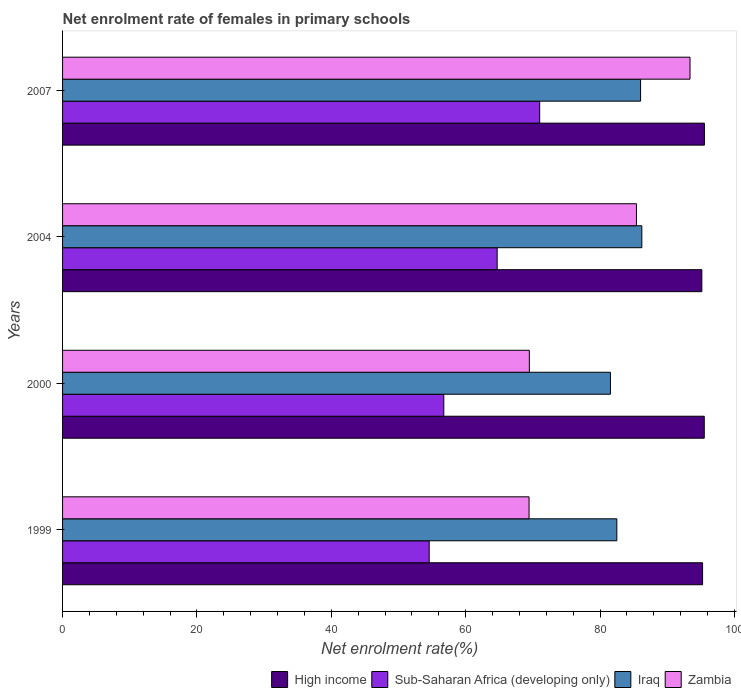How many different coloured bars are there?
Provide a succinct answer. 4. Are the number of bars per tick equal to the number of legend labels?
Provide a succinct answer. Yes. In how many cases, is the number of bars for a given year not equal to the number of legend labels?
Make the answer very short. 0. What is the net enrolment rate of females in primary schools in Sub-Saharan Africa (developing only) in 2007?
Keep it short and to the point. 71.01. Across all years, what is the maximum net enrolment rate of females in primary schools in Zambia?
Provide a short and direct response. 93.38. Across all years, what is the minimum net enrolment rate of females in primary schools in Sub-Saharan Africa (developing only)?
Provide a succinct answer. 54.56. In which year was the net enrolment rate of females in primary schools in Iraq maximum?
Provide a succinct answer. 2004. In which year was the net enrolment rate of females in primary schools in Iraq minimum?
Keep it short and to the point. 2000. What is the total net enrolment rate of females in primary schools in High income in the graph?
Offer a terse response. 381.41. What is the difference between the net enrolment rate of females in primary schools in Iraq in 2000 and that in 2004?
Offer a terse response. -4.67. What is the difference between the net enrolment rate of females in primary schools in Iraq in 2007 and the net enrolment rate of females in primary schools in High income in 1999?
Provide a succinct answer. -9.23. What is the average net enrolment rate of females in primary schools in High income per year?
Ensure brevity in your answer.  95.35. In the year 2000, what is the difference between the net enrolment rate of females in primary schools in High income and net enrolment rate of females in primary schools in Zambia?
Provide a short and direct response. 26.03. In how many years, is the net enrolment rate of females in primary schools in Zambia greater than 88 %?
Give a very brief answer. 1. What is the ratio of the net enrolment rate of females in primary schools in Sub-Saharan Africa (developing only) in 1999 to that in 2000?
Your response must be concise. 0.96. Is the difference between the net enrolment rate of females in primary schools in High income in 2000 and 2007 greater than the difference between the net enrolment rate of females in primary schools in Zambia in 2000 and 2007?
Ensure brevity in your answer.  Yes. What is the difference between the highest and the second highest net enrolment rate of females in primary schools in Sub-Saharan Africa (developing only)?
Provide a succinct answer. 6.33. What is the difference between the highest and the lowest net enrolment rate of females in primary schools in Iraq?
Provide a short and direct response. 4.67. In how many years, is the net enrolment rate of females in primary schools in Zambia greater than the average net enrolment rate of females in primary schools in Zambia taken over all years?
Provide a short and direct response. 2. What does the 1st bar from the bottom in 1999 represents?
Ensure brevity in your answer.  High income. Is it the case that in every year, the sum of the net enrolment rate of females in primary schools in Iraq and net enrolment rate of females in primary schools in High income is greater than the net enrolment rate of females in primary schools in Zambia?
Make the answer very short. Yes. Does the graph contain grids?
Offer a very short reply. No. How are the legend labels stacked?
Provide a short and direct response. Horizontal. What is the title of the graph?
Provide a succinct answer. Net enrolment rate of females in primary schools. Does "Germany" appear as one of the legend labels in the graph?
Offer a terse response. No. What is the label or title of the X-axis?
Your response must be concise. Net enrolment rate(%). What is the Net enrolment rate(%) in High income in 1999?
Offer a very short reply. 95.25. What is the Net enrolment rate(%) in Sub-Saharan Africa (developing only) in 1999?
Keep it short and to the point. 54.56. What is the Net enrolment rate(%) of Iraq in 1999?
Keep it short and to the point. 82.49. What is the Net enrolment rate(%) in Zambia in 1999?
Keep it short and to the point. 69.43. What is the Net enrolment rate(%) of High income in 2000?
Provide a short and direct response. 95.5. What is the Net enrolment rate(%) of Sub-Saharan Africa (developing only) in 2000?
Offer a very short reply. 56.74. What is the Net enrolment rate(%) of Iraq in 2000?
Keep it short and to the point. 81.54. What is the Net enrolment rate(%) of Zambia in 2000?
Give a very brief answer. 69.47. What is the Net enrolment rate(%) of High income in 2004?
Make the answer very short. 95.14. What is the Net enrolment rate(%) of Sub-Saharan Africa (developing only) in 2004?
Offer a very short reply. 64.68. What is the Net enrolment rate(%) of Iraq in 2004?
Keep it short and to the point. 86.21. What is the Net enrolment rate(%) of Zambia in 2004?
Your answer should be very brief. 85.41. What is the Net enrolment rate(%) in High income in 2007?
Make the answer very short. 95.52. What is the Net enrolment rate(%) of Sub-Saharan Africa (developing only) in 2007?
Your response must be concise. 71.01. What is the Net enrolment rate(%) of Iraq in 2007?
Ensure brevity in your answer.  86.02. What is the Net enrolment rate(%) in Zambia in 2007?
Give a very brief answer. 93.38. Across all years, what is the maximum Net enrolment rate(%) in High income?
Ensure brevity in your answer.  95.52. Across all years, what is the maximum Net enrolment rate(%) of Sub-Saharan Africa (developing only)?
Your response must be concise. 71.01. Across all years, what is the maximum Net enrolment rate(%) in Iraq?
Your response must be concise. 86.21. Across all years, what is the maximum Net enrolment rate(%) in Zambia?
Offer a terse response. 93.38. Across all years, what is the minimum Net enrolment rate(%) in High income?
Provide a short and direct response. 95.14. Across all years, what is the minimum Net enrolment rate(%) in Sub-Saharan Africa (developing only)?
Ensure brevity in your answer.  54.56. Across all years, what is the minimum Net enrolment rate(%) in Iraq?
Keep it short and to the point. 81.54. Across all years, what is the minimum Net enrolment rate(%) of Zambia?
Give a very brief answer. 69.43. What is the total Net enrolment rate(%) of High income in the graph?
Provide a short and direct response. 381.41. What is the total Net enrolment rate(%) in Sub-Saharan Africa (developing only) in the graph?
Your response must be concise. 246.99. What is the total Net enrolment rate(%) of Iraq in the graph?
Your answer should be very brief. 336.25. What is the total Net enrolment rate(%) of Zambia in the graph?
Your response must be concise. 317.69. What is the difference between the Net enrolment rate(%) in High income in 1999 and that in 2000?
Your answer should be very brief. -0.25. What is the difference between the Net enrolment rate(%) of Sub-Saharan Africa (developing only) in 1999 and that in 2000?
Keep it short and to the point. -2.17. What is the difference between the Net enrolment rate(%) of Iraq in 1999 and that in 2000?
Your response must be concise. 0.95. What is the difference between the Net enrolment rate(%) in Zambia in 1999 and that in 2000?
Provide a succinct answer. -0.04. What is the difference between the Net enrolment rate(%) of High income in 1999 and that in 2004?
Your answer should be very brief. 0.11. What is the difference between the Net enrolment rate(%) in Sub-Saharan Africa (developing only) in 1999 and that in 2004?
Offer a very short reply. -10.12. What is the difference between the Net enrolment rate(%) of Iraq in 1999 and that in 2004?
Your answer should be very brief. -3.72. What is the difference between the Net enrolment rate(%) in Zambia in 1999 and that in 2004?
Keep it short and to the point. -15.99. What is the difference between the Net enrolment rate(%) of High income in 1999 and that in 2007?
Your response must be concise. -0.27. What is the difference between the Net enrolment rate(%) in Sub-Saharan Africa (developing only) in 1999 and that in 2007?
Give a very brief answer. -16.44. What is the difference between the Net enrolment rate(%) in Iraq in 1999 and that in 2007?
Your response must be concise. -3.53. What is the difference between the Net enrolment rate(%) in Zambia in 1999 and that in 2007?
Offer a terse response. -23.96. What is the difference between the Net enrolment rate(%) in High income in 2000 and that in 2004?
Offer a terse response. 0.36. What is the difference between the Net enrolment rate(%) of Sub-Saharan Africa (developing only) in 2000 and that in 2004?
Your answer should be very brief. -7.94. What is the difference between the Net enrolment rate(%) of Iraq in 2000 and that in 2004?
Give a very brief answer. -4.67. What is the difference between the Net enrolment rate(%) of Zambia in 2000 and that in 2004?
Offer a terse response. -15.94. What is the difference between the Net enrolment rate(%) in High income in 2000 and that in 2007?
Your answer should be very brief. -0.02. What is the difference between the Net enrolment rate(%) of Sub-Saharan Africa (developing only) in 2000 and that in 2007?
Your answer should be compact. -14.27. What is the difference between the Net enrolment rate(%) in Iraq in 2000 and that in 2007?
Offer a terse response. -4.48. What is the difference between the Net enrolment rate(%) of Zambia in 2000 and that in 2007?
Offer a very short reply. -23.91. What is the difference between the Net enrolment rate(%) of High income in 2004 and that in 2007?
Your answer should be very brief. -0.38. What is the difference between the Net enrolment rate(%) in Sub-Saharan Africa (developing only) in 2004 and that in 2007?
Offer a terse response. -6.33. What is the difference between the Net enrolment rate(%) of Iraq in 2004 and that in 2007?
Your answer should be very brief. 0.19. What is the difference between the Net enrolment rate(%) of Zambia in 2004 and that in 2007?
Give a very brief answer. -7.97. What is the difference between the Net enrolment rate(%) of High income in 1999 and the Net enrolment rate(%) of Sub-Saharan Africa (developing only) in 2000?
Offer a terse response. 38.51. What is the difference between the Net enrolment rate(%) of High income in 1999 and the Net enrolment rate(%) of Iraq in 2000?
Offer a terse response. 13.71. What is the difference between the Net enrolment rate(%) in High income in 1999 and the Net enrolment rate(%) in Zambia in 2000?
Your answer should be very brief. 25.78. What is the difference between the Net enrolment rate(%) in Sub-Saharan Africa (developing only) in 1999 and the Net enrolment rate(%) in Iraq in 2000?
Your answer should be very brief. -26.97. What is the difference between the Net enrolment rate(%) of Sub-Saharan Africa (developing only) in 1999 and the Net enrolment rate(%) of Zambia in 2000?
Offer a very short reply. -14.9. What is the difference between the Net enrolment rate(%) in Iraq in 1999 and the Net enrolment rate(%) in Zambia in 2000?
Provide a succinct answer. 13.02. What is the difference between the Net enrolment rate(%) of High income in 1999 and the Net enrolment rate(%) of Sub-Saharan Africa (developing only) in 2004?
Offer a terse response. 30.57. What is the difference between the Net enrolment rate(%) of High income in 1999 and the Net enrolment rate(%) of Iraq in 2004?
Your answer should be very brief. 9.04. What is the difference between the Net enrolment rate(%) in High income in 1999 and the Net enrolment rate(%) in Zambia in 2004?
Your answer should be compact. 9.84. What is the difference between the Net enrolment rate(%) of Sub-Saharan Africa (developing only) in 1999 and the Net enrolment rate(%) of Iraq in 2004?
Provide a short and direct response. -31.65. What is the difference between the Net enrolment rate(%) of Sub-Saharan Africa (developing only) in 1999 and the Net enrolment rate(%) of Zambia in 2004?
Your answer should be compact. -30.85. What is the difference between the Net enrolment rate(%) of Iraq in 1999 and the Net enrolment rate(%) of Zambia in 2004?
Ensure brevity in your answer.  -2.92. What is the difference between the Net enrolment rate(%) of High income in 1999 and the Net enrolment rate(%) of Sub-Saharan Africa (developing only) in 2007?
Your response must be concise. 24.24. What is the difference between the Net enrolment rate(%) of High income in 1999 and the Net enrolment rate(%) of Iraq in 2007?
Make the answer very short. 9.23. What is the difference between the Net enrolment rate(%) in High income in 1999 and the Net enrolment rate(%) in Zambia in 2007?
Provide a short and direct response. 1.87. What is the difference between the Net enrolment rate(%) in Sub-Saharan Africa (developing only) in 1999 and the Net enrolment rate(%) in Iraq in 2007?
Your answer should be compact. -31.46. What is the difference between the Net enrolment rate(%) of Sub-Saharan Africa (developing only) in 1999 and the Net enrolment rate(%) of Zambia in 2007?
Keep it short and to the point. -38.82. What is the difference between the Net enrolment rate(%) of Iraq in 1999 and the Net enrolment rate(%) of Zambia in 2007?
Give a very brief answer. -10.89. What is the difference between the Net enrolment rate(%) in High income in 2000 and the Net enrolment rate(%) in Sub-Saharan Africa (developing only) in 2004?
Offer a terse response. 30.82. What is the difference between the Net enrolment rate(%) of High income in 2000 and the Net enrolment rate(%) of Iraq in 2004?
Offer a very short reply. 9.29. What is the difference between the Net enrolment rate(%) in High income in 2000 and the Net enrolment rate(%) in Zambia in 2004?
Provide a short and direct response. 10.09. What is the difference between the Net enrolment rate(%) of Sub-Saharan Africa (developing only) in 2000 and the Net enrolment rate(%) of Iraq in 2004?
Offer a very short reply. -29.47. What is the difference between the Net enrolment rate(%) in Sub-Saharan Africa (developing only) in 2000 and the Net enrolment rate(%) in Zambia in 2004?
Provide a short and direct response. -28.68. What is the difference between the Net enrolment rate(%) of Iraq in 2000 and the Net enrolment rate(%) of Zambia in 2004?
Your answer should be compact. -3.88. What is the difference between the Net enrolment rate(%) in High income in 2000 and the Net enrolment rate(%) in Sub-Saharan Africa (developing only) in 2007?
Your answer should be very brief. 24.49. What is the difference between the Net enrolment rate(%) of High income in 2000 and the Net enrolment rate(%) of Iraq in 2007?
Provide a succinct answer. 9.48. What is the difference between the Net enrolment rate(%) in High income in 2000 and the Net enrolment rate(%) in Zambia in 2007?
Offer a terse response. 2.12. What is the difference between the Net enrolment rate(%) of Sub-Saharan Africa (developing only) in 2000 and the Net enrolment rate(%) of Iraq in 2007?
Your answer should be very brief. -29.29. What is the difference between the Net enrolment rate(%) of Sub-Saharan Africa (developing only) in 2000 and the Net enrolment rate(%) of Zambia in 2007?
Your response must be concise. -36.65. What is the difference between the Net enrolment rate(%) in Iraq in 2000 and the Net enrolment rate(%) in Zambia in 2007?
Provide a succinct answer. -11.84. What is the difference between the Net enrolment rate(%) of High income in 2004 and the Net enrolment rate(%) of Sub-Saharan Africa (developing only) in 2007?
Your answer should be compact. 24.13. What is the difference between the Net enrolment rate(%) of High income in 2004 and the Net enrolment rate(%) of Iraq in 2007?
Give a very brief answer. 9.12. What is the difference between the Net enrolment rate(%) in High income in 2004 and the Net enrolment rate(%) in Zambia in 2007?
Provide a short and direct response. 1.76. What is the difference between the Net enrolment rate(%) of Sub-Saharan Africa (developing only) in 2004 and the Net enrolment rate(%) of Iraq in 2007?
Your response must be concise. -21.34. What is the difference between the Net enrolment rate(%) in Sub-Saharan Africa (developing only) in 2004 and the Net enrolment rate(%) in Zambia in 2007?
Provide a short and direct response. -28.7. What is the difference between the Net enrolment rate(%) of Iraq in 2004 and the Net enrolment rate(%) of Zambia in 2007?
Provide a succinct answer. -7.17. What is the average Net enrolment rate(%) of High income per year?
Offer a terse response. 95.35. What is the average Net enrolment rate(%) in Sub-Saharan Africa (developing only) per year?
Offer a terse response. 61.75. What is the average Net enrolment rate(%) in Iraq per year?
Provide a short and direct response. 84.06. What is the average Net enrolment rate(%) in Zambia per year?
Your response must be concise. 79.42. In the year 1999, what is the difference between the Net enrolment rate(%) of High income and Net enrolment rate(%) of Sub-Saharan Africa (developing only)?
Your answer should be compact. 40.69. In the year 1999, what is the difference between the Net enrolment rate(%) of High income and Net enrolment rate(%) of Iraq?
Make the answer very short. 12.76. In the year 1999, what is the difference between the Net enrolment rate(%) of High income and Net enrolment rate(%) of Zambia?
Your answer should be compact. 25.82. In the year 1999, what is the difference between the Net enrolment rate(%) of Sub-Saharan Africa (developing only) and Net enrolment rate(%) of Iraq?
Make the answer very short. -27.92. In the year 1999, what is the difference between the Net enrolment rate(%) in Sub-Saharan Africa (developing only) and Net enrolment rate(%) in Zambia?
Keep it short and to the point. -14.86. In the year 1999, what is the difference between the Net enrolment rate(%) in Iraq and Net enrolment rate(%) in Zambia?
Provide a short and direct response. 13.06. In the year 2000, what is the difference between the Net enrolment rate(%) of High income and Net enrolment rate(%) of Sub-Saharan Africa (developing only)?
Make the answer very short. 38.77. In the year 2000, what is the difference between the Net enrolment rate(%) in High income and Net enrolment rate(%) in Iraq?
Your answer should be very brief. 13.96. In the year 2000, what is the difference between the Net enrolment rate(%) in High income and Net enrolment rate(%) in Zambia?
Your response must be concise. 26.03. In the year 2000, what is the difference between the Net enrolment rate(%) in Sub-Saharan Africa (developing only) and Net enrolment rate(%) in Iraq?
Your answer should be very brief. -24.8. In the year 2000, what is the difference between the Net enrolment rate(%) of Sub-Saharan Africa (developing only) and Net enrolment rate(%) of Zambia?
Your answer should be very brief. -12.73. In the year 2000, what is the difference between the Net enrolment rate(%) in Iraq and Net enrolment rate(%) in Zambia?
Your answer should be very brief. 12.07. In the year 2004, what is the difference between the Net enrolment rate(%) of High income and Net enrolment rate(%) of Sub-Saharan Africa (developing only)?
Keep it short and to the point. 30.46. In the year 2004, what is the difference between the Net enrolment rate(%) of High income and Net enrolment rate(%) of Iraq?
Make the answer very short. 8.93. In the year 2004, what is the difference between the Net enrolment rate(%) of High income and Net enrolment rate(%) of Zambia?
Keep it short and to the point. 9.73. In the year 2004, what is the difference between the Net enrolment rate(%) in Sub-Saharan Africa (developing only) and Net enrolment rate(%) in Iraq?
Provide a succinct answer. -21.53. In the year 2004, what is the difference between the Net enrolment rate(%) in Sub-Saharan Africa (developing only) and Net enrolment rate(%) in Zambia?
Make the answer very short. -20.73. In the year 2004, what is the difference between the Net enrolment rate(%) of Iraq and Net enrolment rate(%) of Zambia?
Your answer should be very brief. 0.8. In the year 2007, what is the difference between the Net enrolment rate(%) in High income and Net enrolment rate(%) in Sub-Saharan Africa (developing only)?
Make the answer very short. 24.51. In the year 2007, what is the difference between the Net enrolment rate(%) in High income and Net enrolment rate(%) in Iraq?
Offer a terse response. 9.5. In the year 2007, what is the difference between the Net enrolment rate(%) in High income and Net enrolment rate(%) in Zambia?
Provide a short and direct response. 2.14. In the year 2007, what is the difference between the Net enrolment rate(%) of Sub-Saharan Africa (developing only) and Net enrolment rate(%) of Iraq?
Your answer should be compact. -15.02. In the year 2007, what is the difference between the Net enrolment rate(%) in Sub-Saharan Africa (developing only) and Net enrolment rate(%) in Zambia?
Keep it short and to the point. -22.37. In the year 2007, what is the difference between the Net enrolment rate(%) in Iraq and Net enrolment rate(%) in Zambia?
Your response must be concise. -7.36. What is the ratio of the Net enrolment rate(%) of High income in 1999 to that in 2000?
Provide a succinct answer. 1. What is the ratio of the Net enrolment rate(%) of Sub-Saharan Africa (developing only) in 1999 to that in 2000?
Your response must be concise. 0.96. What is the ratio of the Net enrolment rate(%) in Iraq in 1999 to that in 2000?
Your answer should be very brief. 1.01. What is the ratio of the Net enrolment rate(%) in Sub-Saharan Africa (developing only) in 1999 to that in 2004?
Provide a succinct answer. 0.84. What is the ratio of the Net enrolment rate(%) of Iraq in 1999 to that in 2004?
Provide a short and direct response. 0.96. What is the ratio of the Net enrolment rate(%) of Zambia in 1999 to that in 2004?
Offer a terse response. 0.81. What is the ratio of the Net enrolment rate(%) in High income in 1999 to that in 2007?
Keep it short and to the point. 1. What is the ratio of the Net enrolment rate(%) of Sub-Saharan Africa (developing only) in 1999 to that in 2007?
Provide a succinct answer. 0.77. What is the ratio of the Net enrolment rate(%) in Iraq in 1999 to that in 2007?
Provide a succinct answer. 0.96. What is the ratio of the Net enrolment rate(%) of Zambia in 1999 to that in 2007?
Your response must be concise. 0.74. What is the ratio of the Net enrolment rate(%) in High income in 2000 to that in 2004?
Provide a succinct answer. 1. What is the ratio of the Net enrolment rate(%) of Sub-Saharan Africa (developing only) in 2000 to that in 2004?
Provide a succinct answer. 0.88. What is the ratio of the Net enrolment rate(%) in Iraq in 2000 to that in 2004?
Ensure brevity in your answer.  0.95. What is the ratio of the Net enrolment rate(%) in Zambia in 2000 to that in 2004?
Provide a succinct answer. 0.81. What is the ratio of the Net enrolment rate(%) of High income in 2000 to that in 2007?
Ensure brevity in your answer.  1. What is the ratio of the Net enrolment rate(%) of Sub-Saharan Africa (developing only) in 2000 to that in 2007?
Your answer should be very brief. 0.8. What is the ratio of the Net enrolment rate(%) in Iraq in 2000 to that in 2007?
Ensure brevity in your answer.  0.95. What is the ratio of the Net enrolment rate(%) of Zambia in 2000 to that in 2007?
Give a very brief answer. 0.74. What is the ratio of the Net enrolment rate(%) of High income in 2004 to that in 2007?
Make the answer very short. 1. What is the ratio of the Net enrolment rate(%) of Sub-Saharan Africa (developing only) in 2004 to that in 2007?
Keep it short and to the point. 0.91. What is the ratio of the Net enrolment rate(%) of Iraq in 2004 to that in 2007?
Give a very brief answer. 1. What is the ratio of the Net enrolment rate(%) in Zambia in 2004 to that in 2007?
Offer a very short reply. 0.91. What is the difference between the highest and the second highest Net enrolment rate(%) of High income?
Ensure brevity in your answer.  0.02. What is the difference between the highest and the second highest Net enrolment rate(%) of Sub-Saharan Africa (developing only)?
Your answer should be compact. 6.33. What is the difference between the highest and the second highest Net enrolment rate(%) in Iraq?
Your answer should be very brief. 0.19. What is the difference between the highest and the second highest Net enrolment rate(%) of Zambia?
Your answer should be very brief. 7.97. What is the difference between the highest and the lowest Net enrolment rate(%) in High income?
Ensure brevity in your answer.  0.38. What is the difference between the highest and the lowest Net enrolment rate(%) in Sub-Saharan Africa (developing only)?
Keep it short and to the point. 16.44. What is the difference between the highest and the lowest Net enrolment rate(%) of Iraq?
Your answer should be compact. 4.67. What is the difference between the highest and the lowest Net enrolment rate(%) in Zambia?
Ensure brevity in your answer.  23.96. 